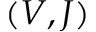<formula> <loc_0><loc_0><loc_500><loc_500>( V , J )</formula> 